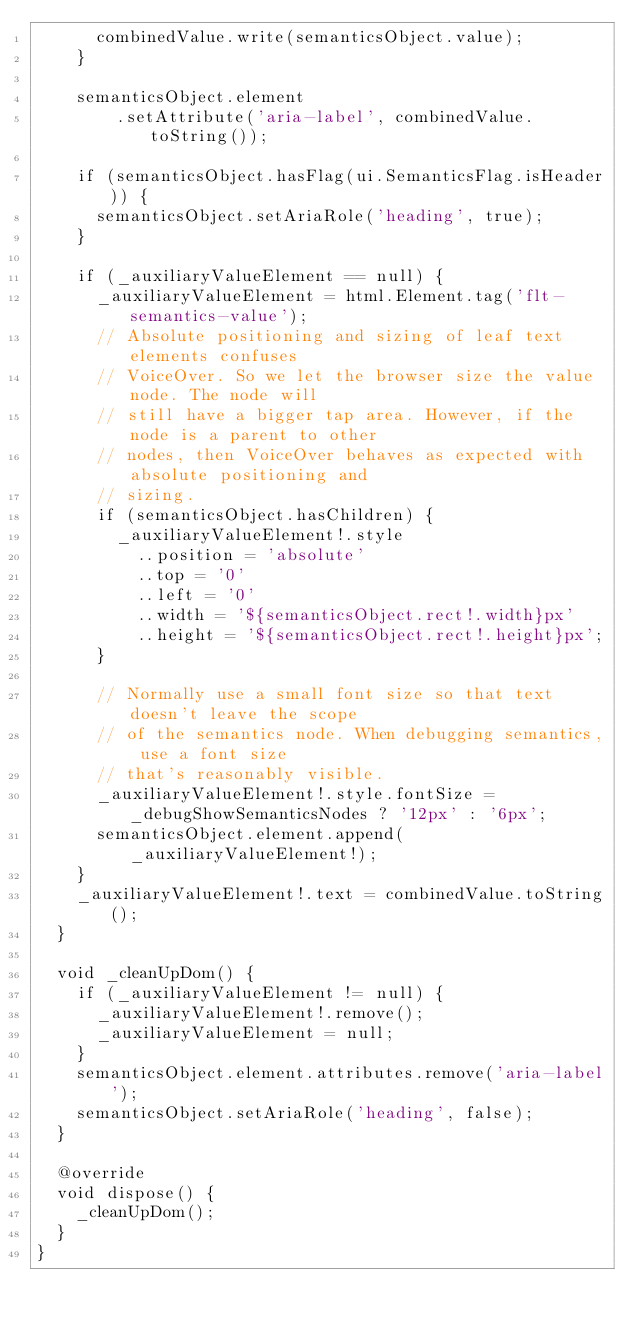Convert code to text. <code><loc_0><loc_0><loc_500><loc_500><_Dart_>      combinedValue.write(semanticsObject.value);
    }

    semanticsObject.element
        .setAttribute('aria-label', combinedValue.toString());

    if (semanticsObject.hasFlag(ui.SemanticsFlag.isHeader)) {
      semanticsObject.setAriaRole('heading', true);
    }

    if (_auxiliaryValueElement == null) {
      _auxiliaryValueElement = html.Element.tag('flt-semantics-value');
      // Absolute positioning and sizing of leaf text elements confuses
      // VoiceOver. So we let the browser size the value node. The node will
      // still have a bigger tap area. However, if the node is a parent to other
      // nodes, then VoiceOver behaves as expected with absolute positioning and
      // sizing.
      if (semanticsObject.hasChildren) {
        _auxiliaryValueElement!.style
          ..position = 'absolute'
          ..top = '0'
          ..left = '0'
          ..width = '${semanticsObject.rect!.width}px'
          ..height = '${semanticsObject.rect!.height}px';
      }

      // Normally use a small font size so that text doesn't leave the scope
      // of the semantics node. When debugging semantics, use a font size
      // that's reasonably visible.
      _auxiliaryValueElement!.style.fontSize = _debugShowSemanticsNodes ? '12px' : '6px';
      semanticsObject.element.append(_auxiliaryValueElement!);
    }
    _auxiliaryValueElement!.text = combinedValue.toString();
  }

  void _cleanUpDom() {
    if (_auxiliaryValueElement != null) {
      _auxiliaryValueElement!.remove();
      _auxiliaryValueElement = null;
    }
    semanticsObject.element.attributes.remove('aria-label');
    semanticsObject.setAriaRole('heading', false);
  }

  @override
  void dispose() {
    _cleanUpDom();
  }
}
</code> 